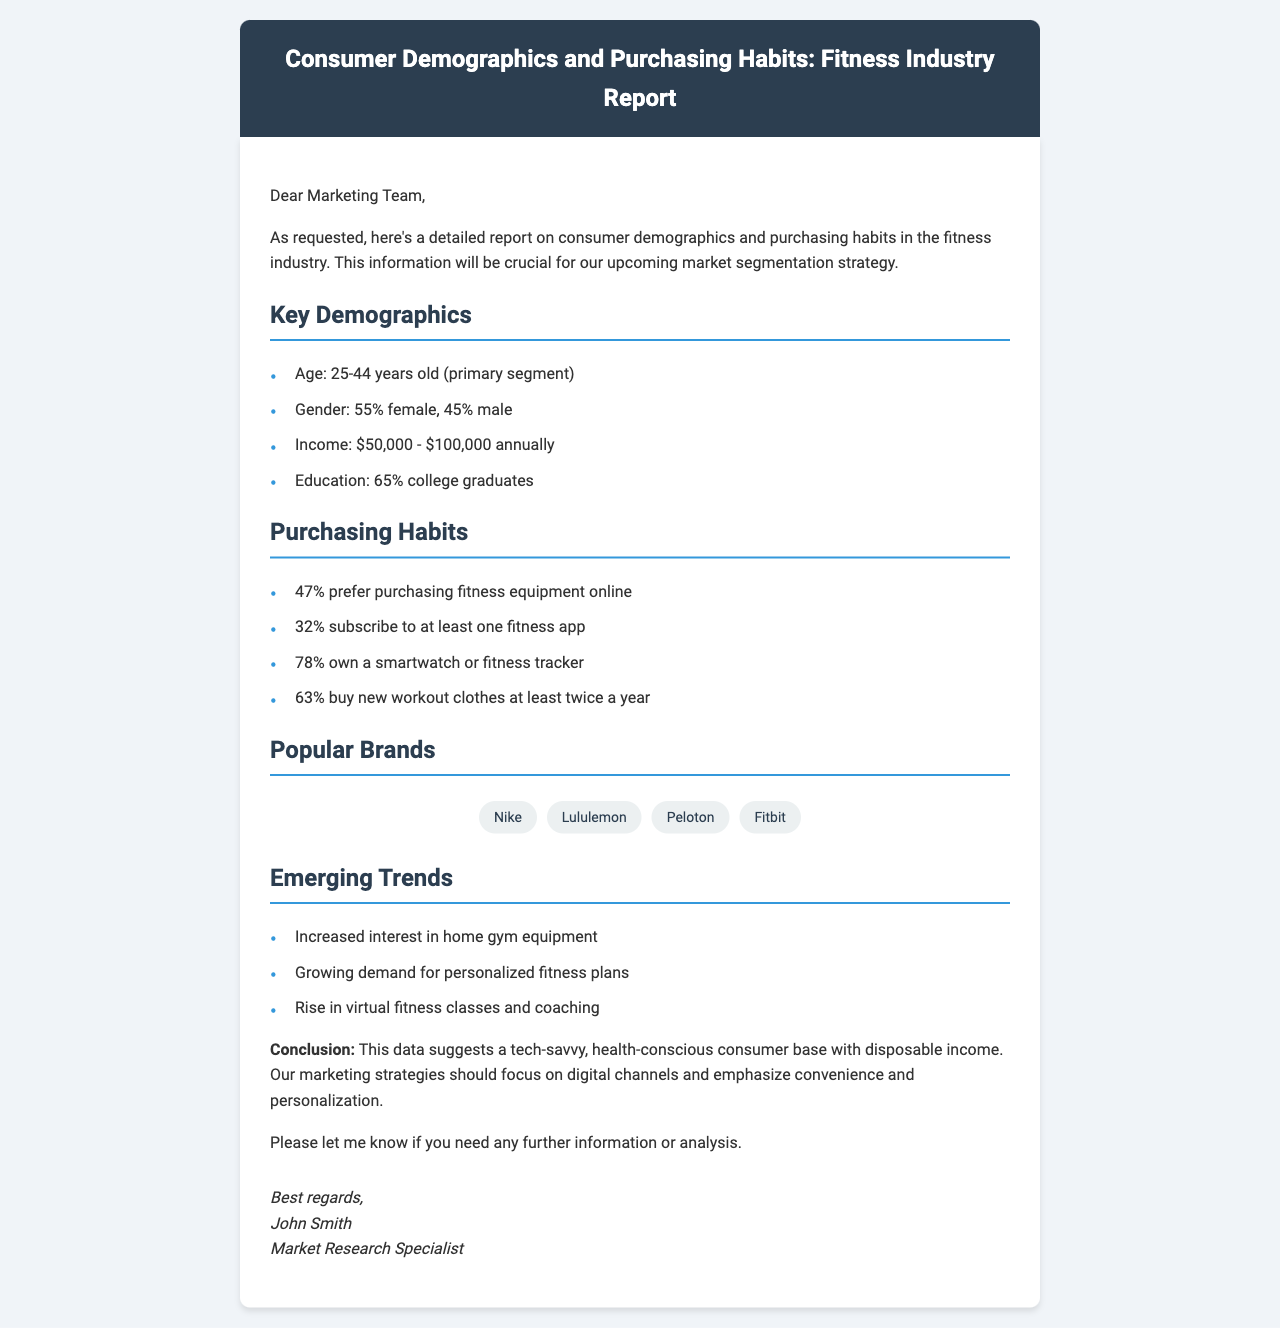What is the primary age segment? The primary age segment is specified in the key demographics section of the report, which states that the age group is 25-44 years old.
Answer: 25-44 years old What percentage of consumers own a smartwatch or fitness tracker? The report mentions that 78% of consumers own a smartwatch or fitness tracker in the purchasing habits section.
Answer: 78% What is the annual income range of the targeted demographics? The report specifies the income range for the target demographics as $50,000 - $100,000 annually.
Answer: $50,000 - $100,000 Which brand is listed first under popular brands? The order of popular brands is mentioned in the brand section of the report, with Nike being the first listed brand.
Answer: Nike Which purchasing habit has the highest percentage? The highest percentage of purchasing habits is indicated in the document, where 78% of consumers own a smartwatch or fitness tracker, making it the highest.
Answer: 78% What emerging trend focuses on home equipment? The report discusses several trends, and the one related to home equipment is "Increased interest in home gym equipment."
Answer: Increased interest in home gym equipment What percentage of consumers prefer purchasing fitness equipment online? The document specifies that 47% of consumers prefer purchasing fitness equipment online, as highlighted in the purchasing habits section.
Answer: 47% What is the main conclusion drawn from the data? The conclusion emphasizes the characteristics of the consumer base as tech-savvy and health-conscious, which is summarized in one phrase in the conclusion section.
Answer: tech-savvy, health-conscious consumer base 